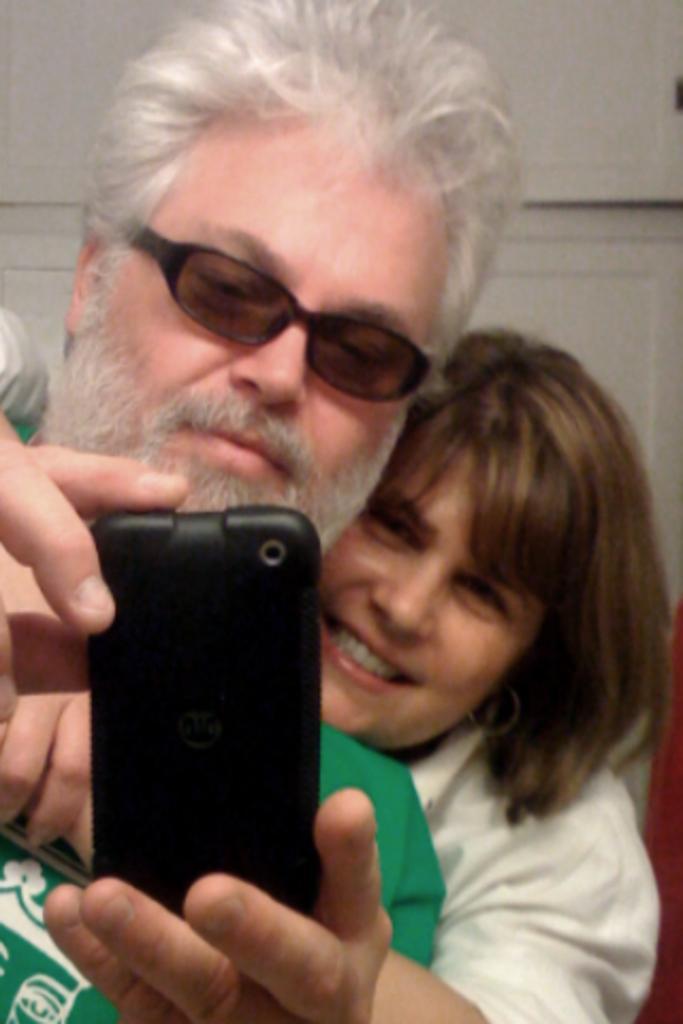Can you describe this image briefly? In this image there are two persons one behind the other holding mobile phone. Person wearing a green shirt is having spectacles. 